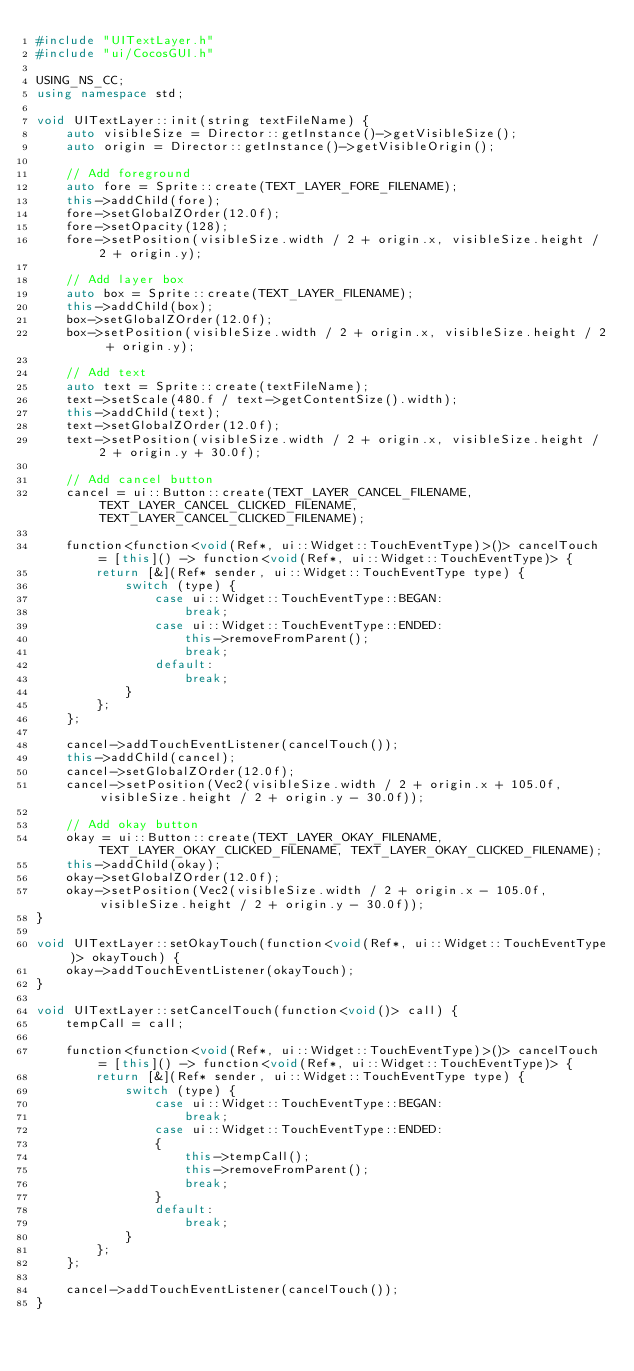Convert code to text. <code><loc_0><loc_0><loc_500><loc_500><_C++_>#include "UITextLayer.h"
#include "ui/CocosGUI.h"

USING_NS_CC;
using namespace std;

void UITextLayer::init(string textFileName) {
    auto visibleSize = Director::getInstance()->getVisibleSize();
    auto origin = Director::getInstance()->getVisibleOrigin();

    // Add foreground
    auto fore = Sprite::create(TEXT_LAYER_FORE_FILENAME);
    this->addChild(fore);
    fore->setGlobalZOrder(12.0f);
    fore->setOpacity(128);
    fore->setPosition(visibleSize.width / 2 + origin.x, visibleSize.height / 2 + origin.y);

    // Add layer box
    auto box = Sprite::create(TEXT_LAYER_FILENAME);
    this->addChild(box);
    box->setGlobalZOrder(12.0f);
    box->setPosition(visibleSize.width / 2 + origin.x, visibleSize.height / 2 + origin.y);

    // Add text
    auto text = Sprite::create(textFileName);
    text->setScale(480.f / text->getContentSize().width);
    this->addChild(text);
    text->setGlobalZOrder(12.0f);
    text->setPosition(visibleSize.width / 2 + origin.x, visibleSize.height / 2 + origin.y + 30.0f);

    // Add cancel button
    cancel = ui::Button::create(TEXT_LAYER_CANCEL_FILENAME, TEXT_LAYER_CANCEL_CLICKED_FILENAME, TEXT_LAYER_CANCEL_CLICKED_FILENAME);
    
    function<function<void(Ref*, ui::Widget::TouchEventType)>()> cancelTouch = [this]() -> function<void(Ref*, ui::Widget::TouchEventType)> {
        return [&](Ref* sender, ui::Widget::TouchEventType type) {
            switch (type) {
                case ui::Widget::TouchEventType::BEGAN:
                    break;
                case ui::Widget::TouchEventType::ENDED:  
                    this->removeFromParent();   
                    break;
                default:
                    break;
            }
        };
    };
    
    cancel->addTouchEventListener(cancelTouch());
    this->addChild(cancel);
    cancel->setGlobalZOrder(12.0f);
    cancel->setPosition(Vec2(visibleSize.width / 2 + origin.x + 105.0f, visibleSize.height / 2 + origin.y - 30.0f));

    // Add okay button
    okay = ui::Button::create(TEXT_LAYER_OKAY_FILENAME, TEXT_LAYER_OKAY_CLICKED_FILENAME, TEXT_LAYER_OKAY_CLICKED_FILENAME);
    this->addChild(okay);
    okay->setGlobalZOrder(12.0f);
    okay->setPosition(Vec2(visibleSize.width / 2 + origin.x - 105.0f, visibleSize.height / 2 + origin.y - 30.0f));
}

void UITextLayer::setOkayTouch(function<void(Ref*, ui::Widget::TouchEventType)> okayTouch) {
    okay->addTouchEventListener(okayTouch);
}

void UITextLayer::setCancelTouch(function<void()> call) {
    tempCall = call;

    function<function<void(Ref*, ui::Widget::TouchEventType)>()> cancelTouch = [this]() -> function<void(Ref*, ui::Widget::TouchEventType)> {
        return [&](Ref* sender, ui::Widget::TouchEventType type) {
            switch (type) {
                case ui::Widget::TouchEventType::BEGAN:
                    break;
                case ui::Widget::TouchEventType::ENDED:
                {    
                    this->tempCall();
                    this->removeFromParent();   
                    break;
                }
                default:
                    break;
            }
        };
    };

    cancel->addTouchEventListener(cancelTouch());
}</code> 